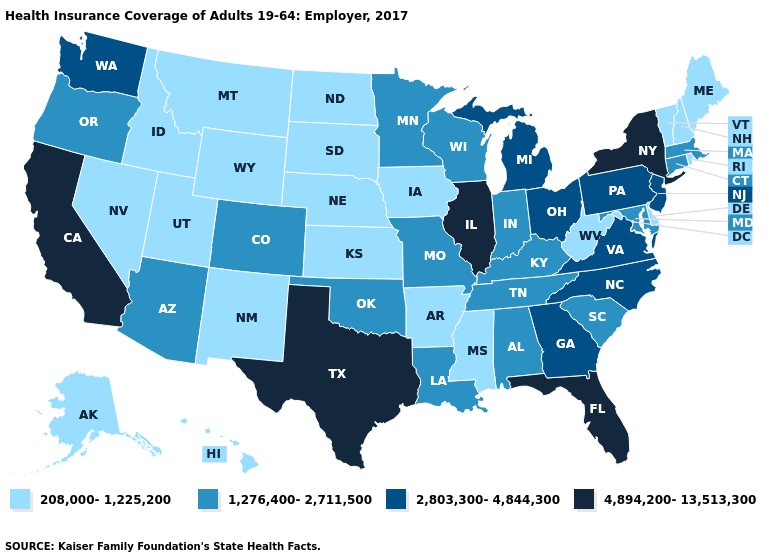Name the states that have a value in the range 4,894,200-13,513,300?
Short answer required. California, Florida, Illinois, New York, Texas. Name the states that have a value in the range 208,000-1,225,200?
Be succinct. Alaska, Arkansas, Delaware, Hawaii, Idaho, Iowa, Kansas, Maine, Mississippi, Montana, Nebraska, Nevada, New Hampshire, New Mexico, North Dakota, Rhode Island, South Dakota, Utah, Vermont, West Virginia, Wyoming. Name the states that have a value in the range 1,276,400-2,711,500?
Write a very short answer. Alabama, Arizona, Colorado, Connecticut, Indiana, Kentucky, Louisiana, Maryland, Massachusetts, Minnesota, Missouri, Oklahoma, Oregon, South Carolina, Tennessee, Wisconsin. Name the states that have a value in the range 208,000-1,225,200?
Answer briefly. Alaska, Arkansas, Delaware, Hawaii, Idaho, Iowa, Kansas, Maine, Mississippi, Montana, Nebraska, Nevada, New Hampshire, New Mexico, North Dakota, Rhode Island, South Dakota, Utah, Vermont, West Virginia, Wyoming. Does the map have missing data?
Short answer required. No. Does Nevada have a lower value than South Carolina?
Write a very short answer. Yes. Among the states that border Louisiana , does Texas have the lowest value?
Be succinct. No. What is the highest value in the South ?
Concise answer only. 4,894,200-13,513,300. What is the value of South Dakota?
Keep it brief. 208,000-1,225,200. Is the legend a continuous bar?
Give a very brief answer. No. Which states have the highest value in the USA?
Answer briefly. California, Florida, Illinois, New York, Texas. Name the states that have a value in the range 1,276,400-2,711,500?
Quick response, please. Alabama, Arizona, Colorado, Connecticut, Indiana, Kentucky, Louisiana, Maryland, Massachusetts, Minnesota, Missouri, Oklahoma, Oregon, South Carolina, Tennessee, Wisconsin. Does Michigan have a lower value than Florida?
Be succinct. Yes. What is the value of Utah?
Give a very brief answer. 208,000-1,225,200. Does the first symbol in the legend represent the smallest category?
Quick response, please. Yes. 